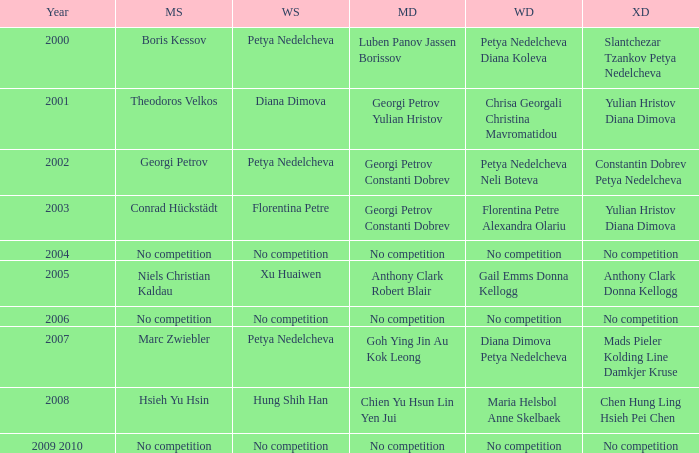Who won the Men's Double the same year as Florentina Petre winning the Women's Singles? Georgi Petrov Constanti Dobrev. 